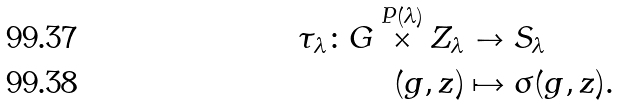<formula> <loc_0><loc_0><loc_500><loc_500>\tau _ { \lambda } \colon G \overset { P ( \lambda ) } { \times } Z _ { \lambda } & \to S _ { \lambda } \\ ( g , z ) & \mapsto \sigma ( g , z ) .</formula> 